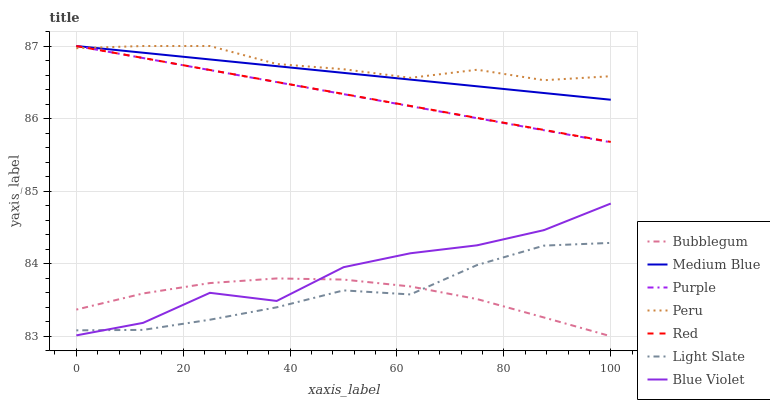Does Medium Blue have the minimum area under the curve?
Answer yes or no. No. Does Medium Blue have the maximum area under the curve?
Answer yes or no. No. Is Bubblegum the smoothest?
Answer yes or no. No. Is Bubblegum the roughest?
Answer yes or no. No. Does Medium Blue have the lowest value?
Answer yes or no. No. Does Bubblegum have the highest value?
Answer yes or no. No. Is Bubblegum less than Peru?
Answer yes or no. Yes. Is Red greater than Bubblegum?
Answer yes or no. Yes. Does Bubblegum intersect Peru?
Answer yes or no. No. 